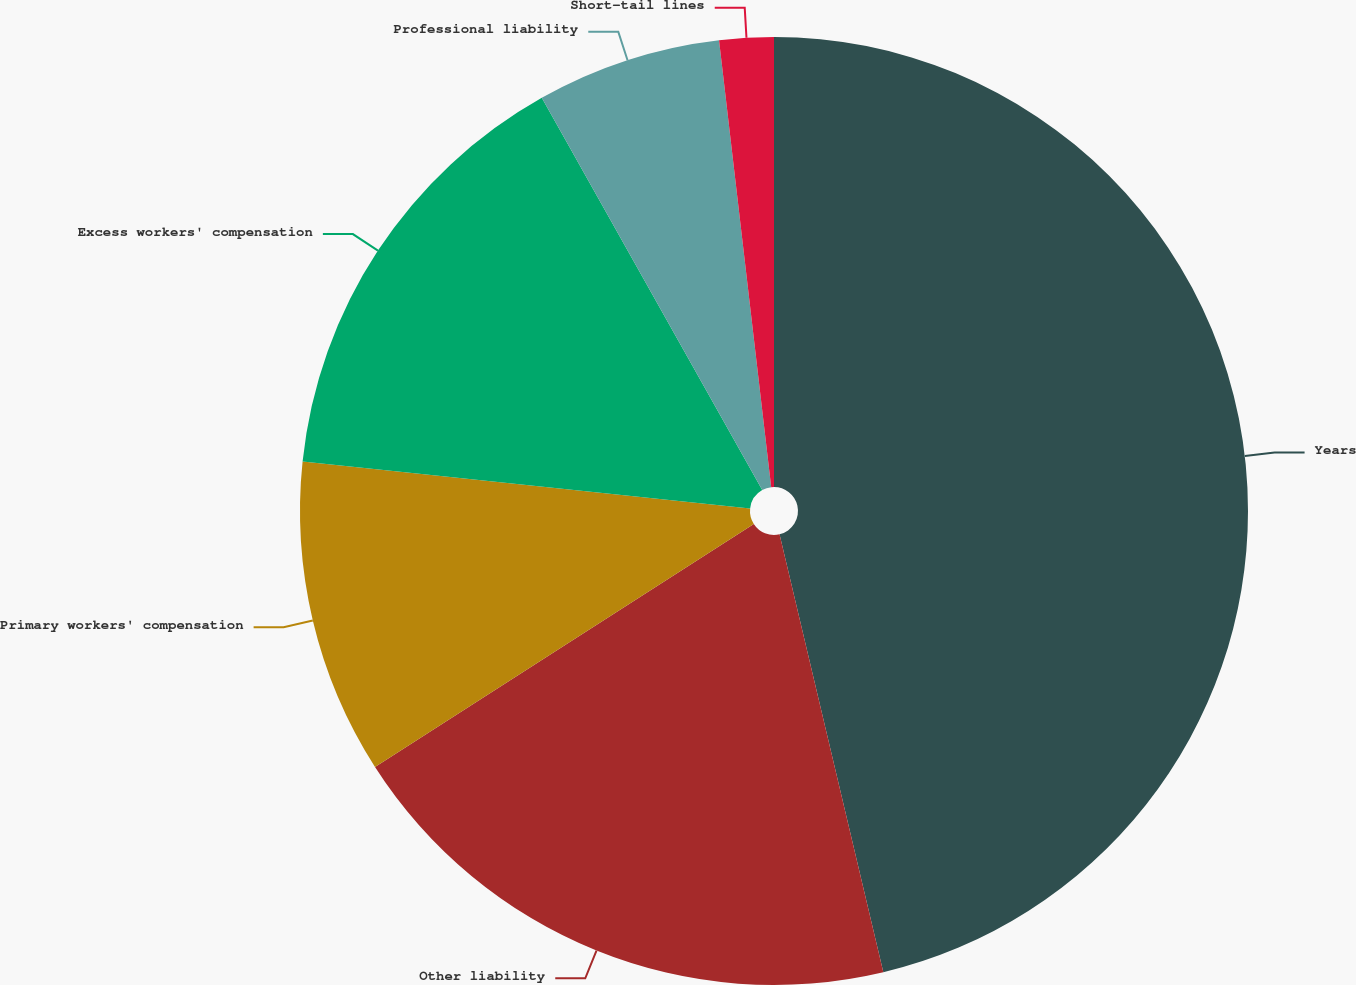<chart> <loc_0><loc_0><loc_500><loc_500><pie_chart><fcel>Years<fcel>Other liability<fcel>Primary workers' compensation<fcel>Excess workers' compensation<fcel>Professional liability<fcel>Short-tail lines<nl><fcel>46.3%<fcel>19.63%<fcel>10.74%<fcel>15.19%<fcel>6.3%<fcel>1.85%<nl></chart> 